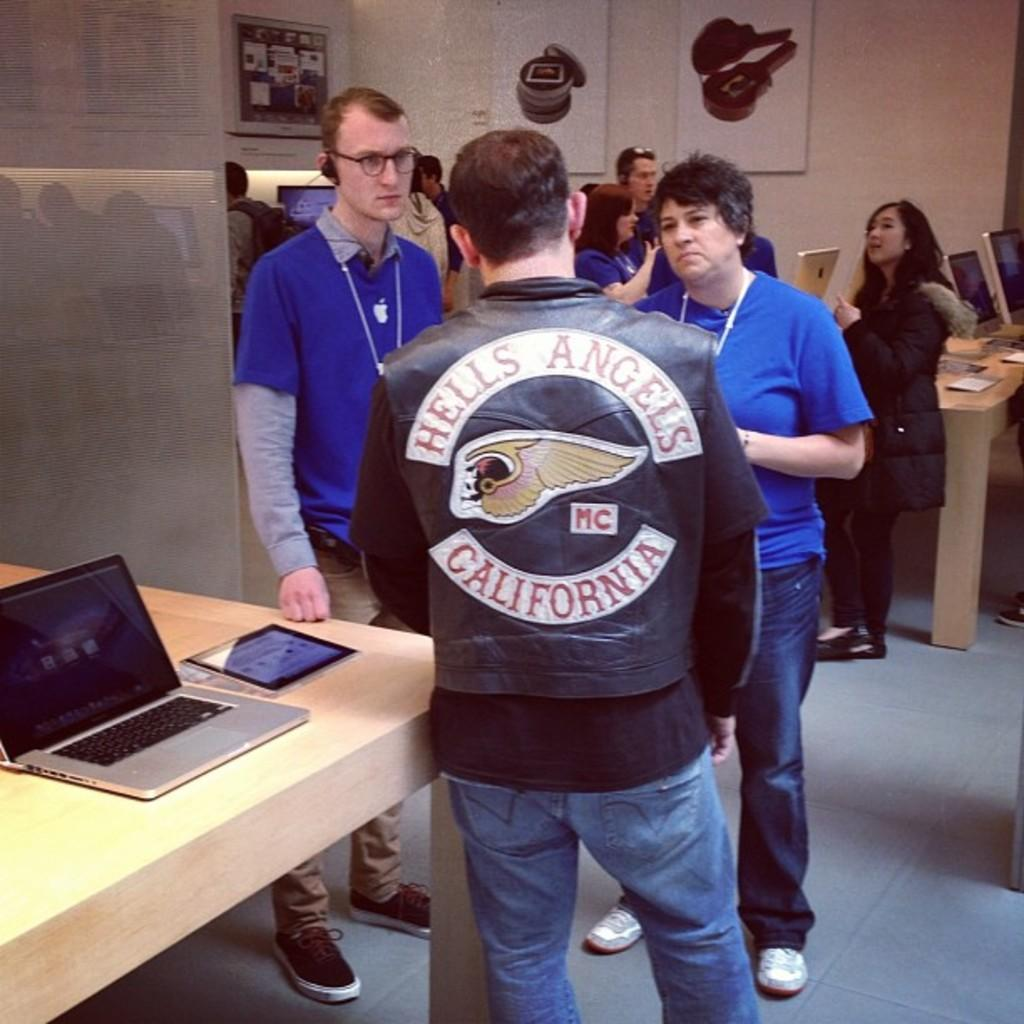How many people are in the image? There is a group of people in the image. Where are the people standing? The people are standing on a floor. What can be seen on the table in the image? There is a laptop and an iPad on the table. What type of electronic devices are present in the image? There is a laptop and an iPad on the table. What type of glove is being used by the people in the image? There is no glove present in the image. Can you see any geese in the image? There are no geese present in the image. 